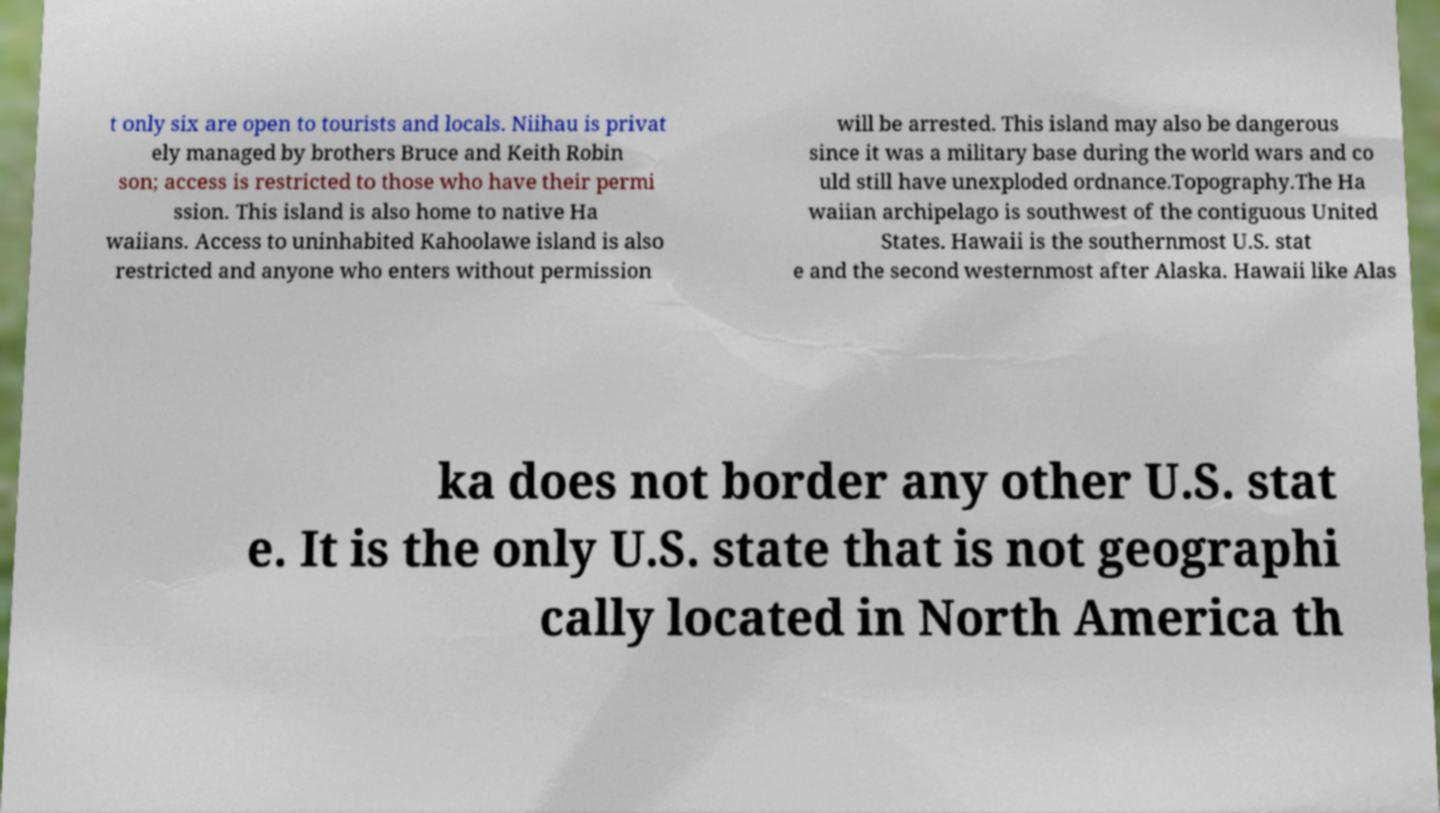Could you extract and type out the text from this image? t only six are open to tourists and locals. Niihau is privat ely managed by brothers Bruce and Keith Robin son; access is restricted to those who have their permi ssion. This island is also home to native Ha waiians. Access to uninhabited Kahoolawe island is also restricted and anyone who enters without permission will be arrested. This island may also be dangerous since it was a military base during the world wars and co uld still have unexploded ordnance.Topography.The Ha waiian archipelago is southwest of the contiguous United States. Hawaii is the southernmost U.S. stat e and the second westernmost after Alaska. Hawaii like Alas ka does not border any other U.S. stat e. It is the only U.S. state that is not geographi cally located in North America th 